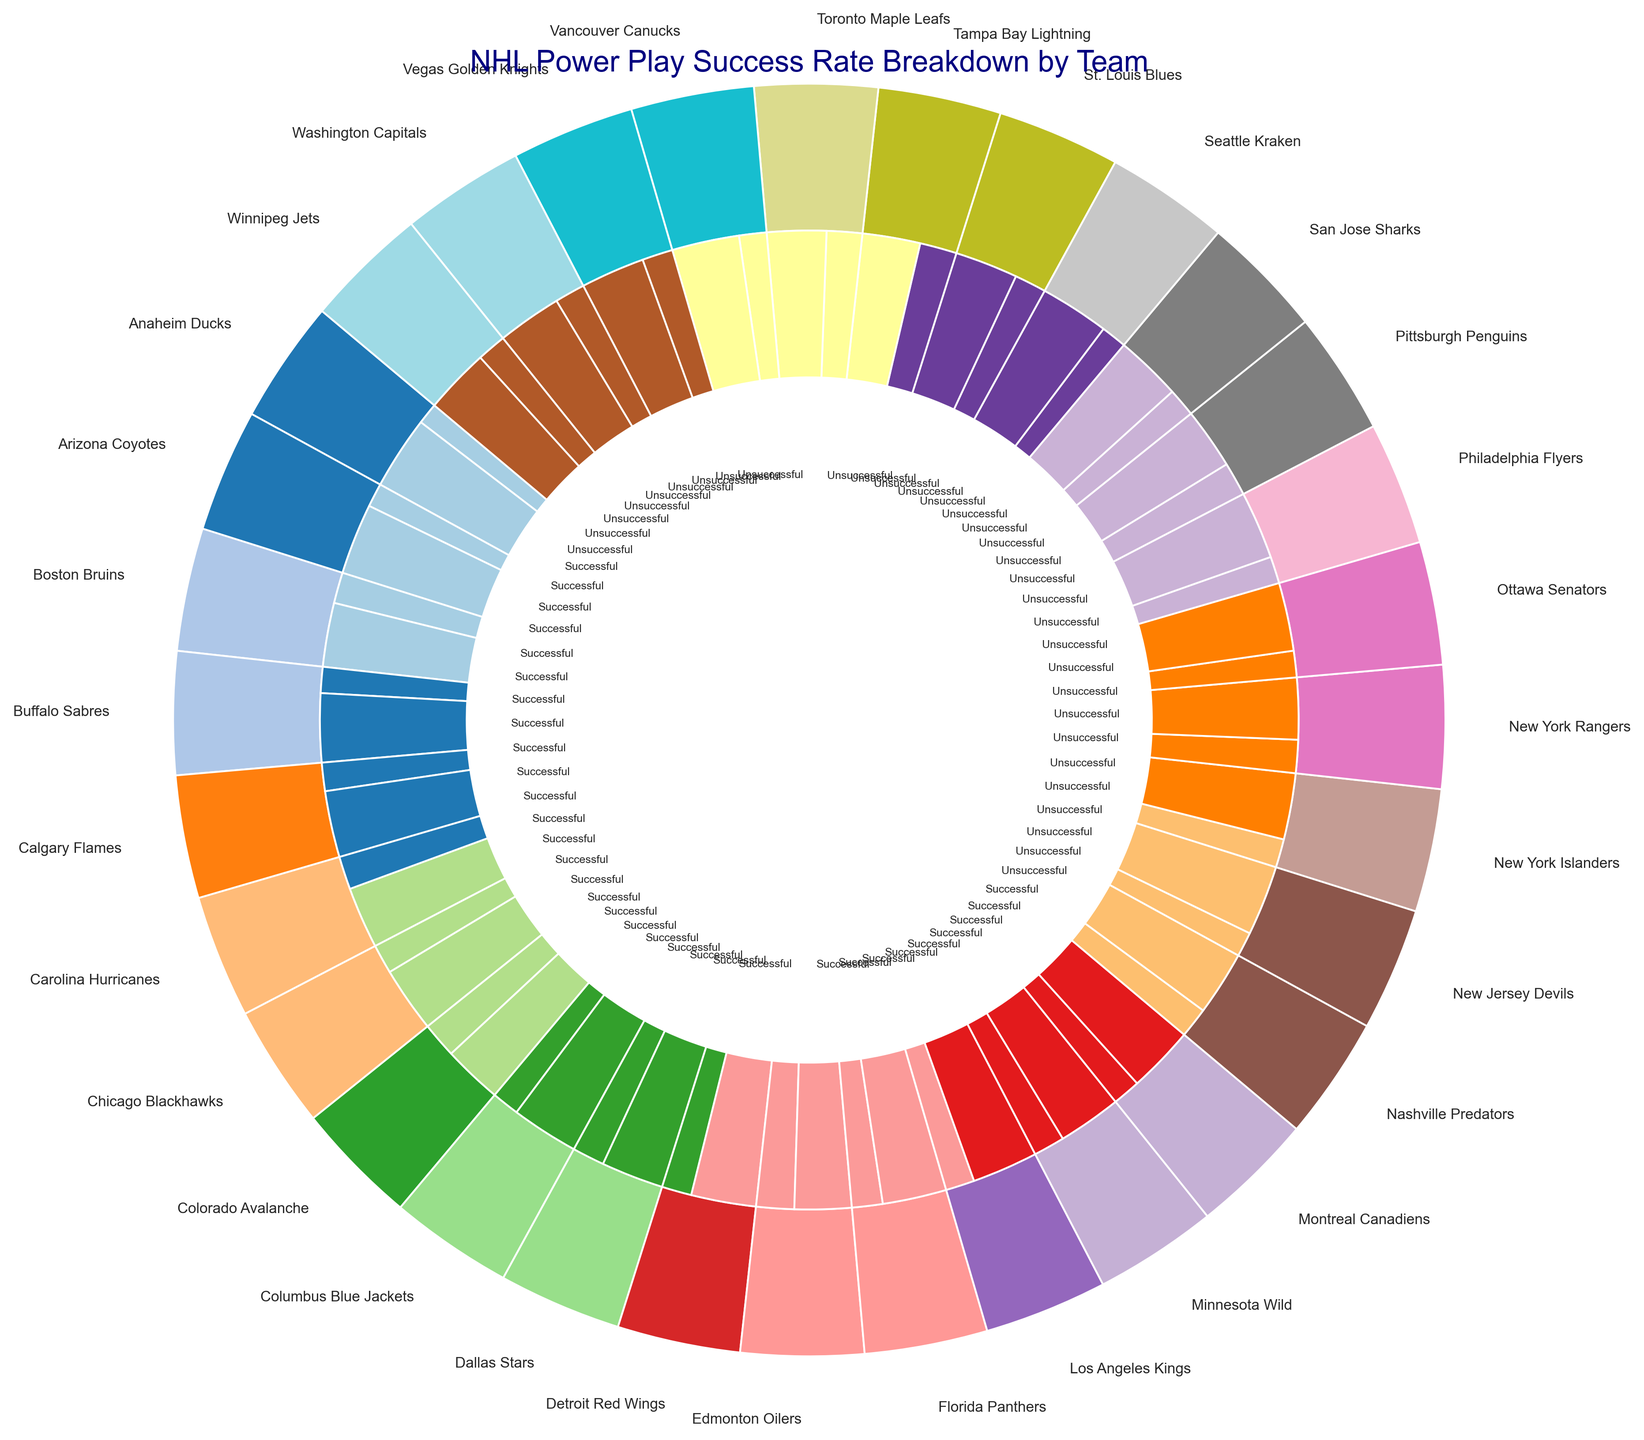Which team has the highest number of successful power plays? To determine this, look at the inner section labeled "Successful" for each team. Identify the team with the largest segment in this category.
Answer: Edmonton Oilers Which team has the highest total power play attempts? To determine this, look at the outer pie chart and identify the team with the largest segment, which represents the total attempts.
Answer: Anaheim Ducks What is the success rate of the Arizona Coyotes' power plays? First, find the Arizona Coyotes section in the outer pie chart to get the total attempts. Then, look at the inner pie chart to see how many are successful. Use the formula (Successful / Total) to calculate the rate: (50 / (50 + 150)) * 100%.
Answer: 25% Are the New York Rangers or New Jersey Devils more successful in power play attempts? Compare the inner "Successful" sections for both teams. The team with the larger segment has more successful attempts.
Answer: New York Rangers Which team has more unsuccessful power play attempts, the New Jersey Devils or the Ottawa Senators? Compare the inner "Unsuccessful" segments for both the New Jersey Devils and Ottawa Senators. The team with the larger segment has more unsuccessful attempts.
Answer: New Jersey Devils Which teams have an equal number of successful power play attempts? Look at the inner pie chart for segments labeled "Successful" and identify any segments with the same size/counts.
Answer: Boston Bruins, Florida Panthers, Vegas Golden Knights Which team has a higher success rate, the Colorado Avalanche or the Tampa Bay Lightning? Calculate the success rate for both teams using the formula (Successful / Total) and compare:
  - Colorado Avalanche: (75 / (75 + 125)) * 100%
  - Tampa Bay Lightning: (78 / (78 + 122)) * 100%
Answer: Tampa Bay Lightning Which teams have a success rate over 35%? Calculate the success rate for each team, find those higher than 35%:
  - Edmonton Oilers: (80 / (80 + 120)) * 100% ≈ 40%
  - Tampa Bay Lightning: (78 / (78 + 122)) * 100% ≈ 39%
  - Pittsburgh Penguins: (71 / (71 + 129)) * 100% ≈ 35.5%
  - Colorado Avalanche: (75 / (75 + 125)) * 100% ≈ 37.5%
Answer: Edmonton Oilers, Tampa Bay Lightning, Pittsburgh Penguins, Colorado Avalanche What is the difference in total power play attempts between the Anaheim Ducks and the New Jersey Devils? Calculate the total attempts for both teams:
  - Anaheim Ducks: 45 (Successful) + 155 (Unsuccessful) = 200
  - New Jersey Devils: 52 (Successful) + 148 (Unsuccessful) = 200
  - Difference = 200 - 200
Answer: 0 How does the total number of successful attempts of the Detroit Red Wings compare to the Chicago Blackhawks? Compare the size of the inner "Successful" segments for the Detroit Red Wings and the Chicago Blackhawks. The team with the larger segment has more successful attempts.
Answer: Chicago Blackhawks 